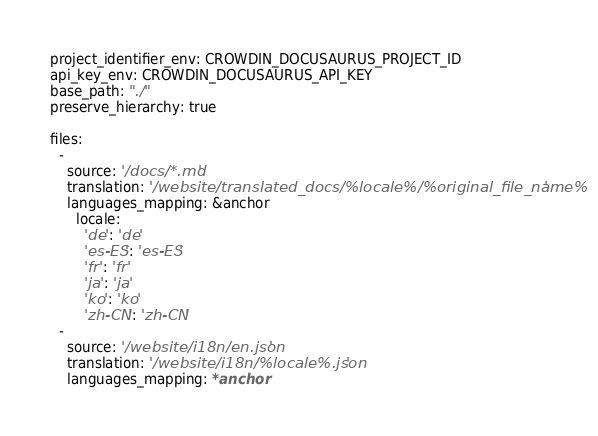Convert code to text. <code><loc_0><loc_0><loc_500><loc_500><_YAML_>project_identifier_env: CROWDIN_DOCUSAURUS_PROJECT_ID
api_key_env: CROWDIN_DOCUSAURUS_API_KEY
base_path: "./"
preserve_hierarchy: true

files:
  -
    source: '/docs/*.md'
    translation: '/website/translated_docs/%locale%/%original_file_name%'
    languages_mapping: &anchor
      locale:
        'de': 'de'
        'es-ES': 'es-ES'
        'fr': 'fr'
        'ja': 'ja'
        'ko': 'ko'
        'zh-CN': 'zh-CN'
  -
    source: '/website/i18n/en.json'
    translation: '/website/i18n/%locale%.json'
    languages_mapping: *anchor
</code> 